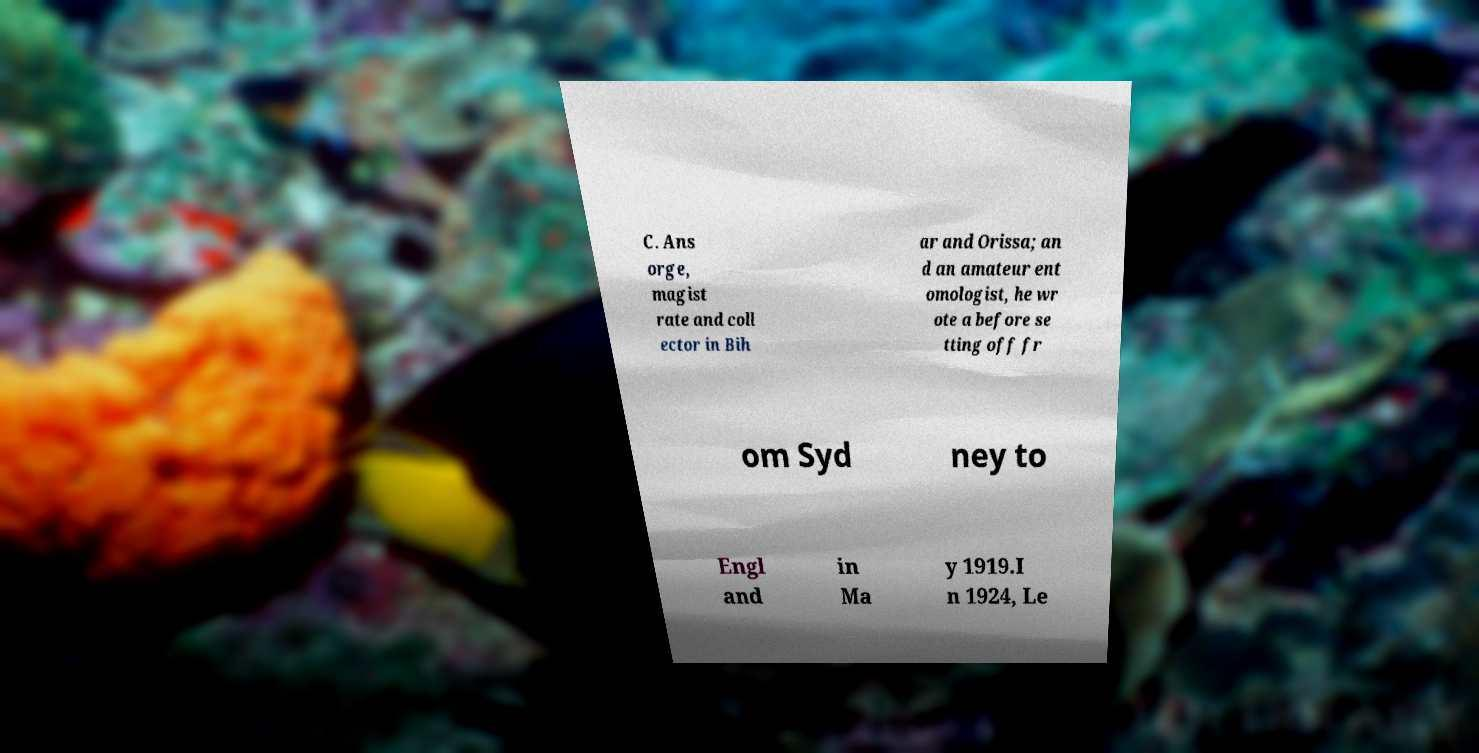There's text embedded in this image that I need extracted. Can you transcribe it verbatim? C. Ans orge, magist rate and coll ector in Bih ar and Orissa; an d an amateur ent omologist, he wr ote a before se tting off fr om Syd ney to Engl and in Ma y 1919.I n 1924, Le 